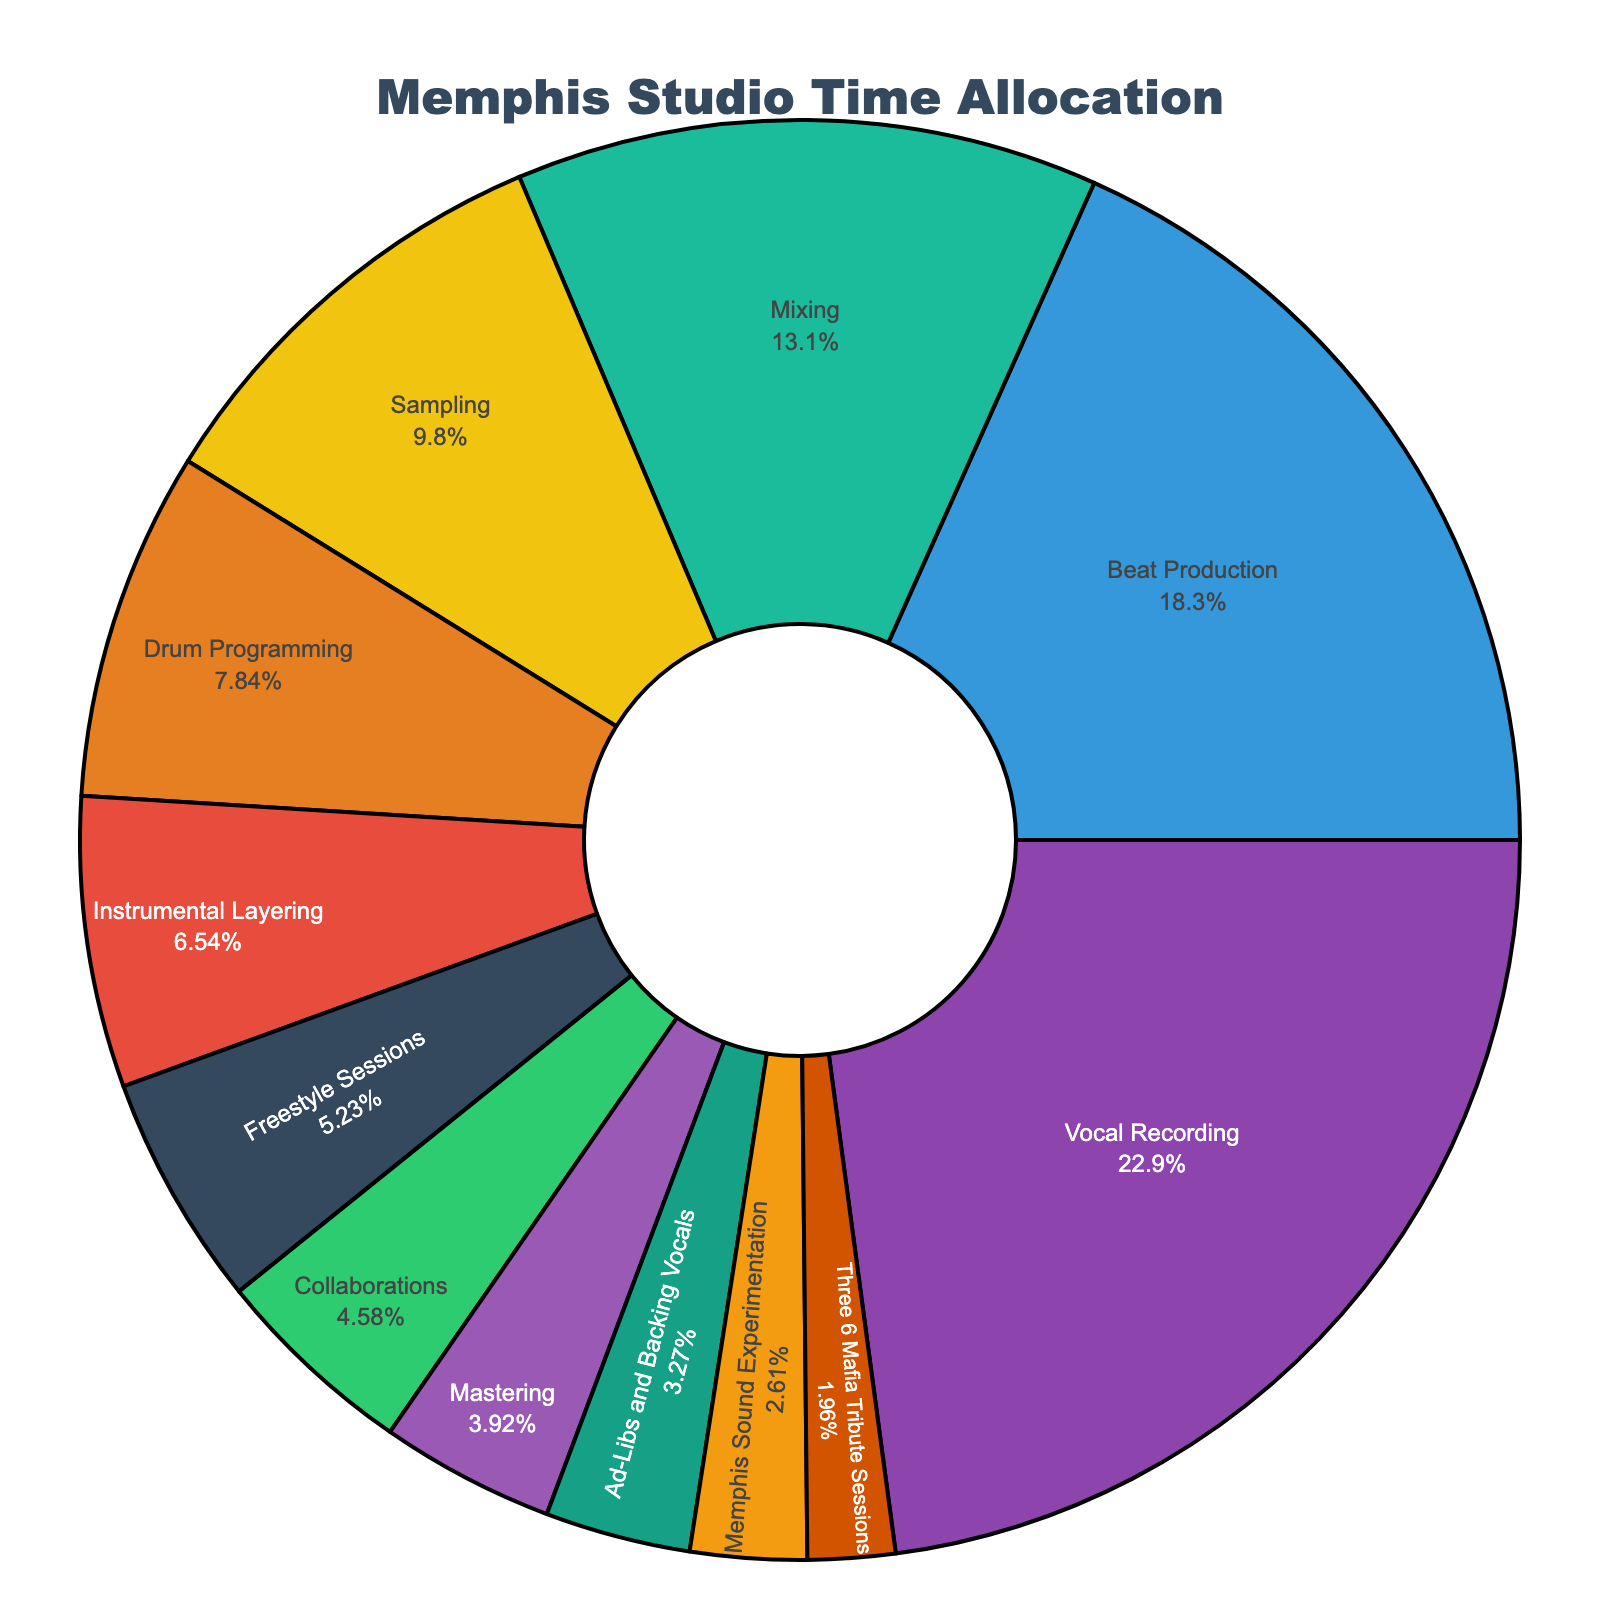How much time, in total, is dedicated to elements typical of Memphis hip-hop, specifically Memphis Sound Experimentation and Three 6 Mafia Tribute Sessions? To find the total time dedicated to Memphis-specific elements, add the hours for Memphis Sound Experimentation (4) and Three 6 Mafia Tribute Sessions (3). So, 4 + 3 = 7 hours.
Answer: 7 hours Which element takes up the largest portion of the studio time? Identify the element with the highest value. From the data, Vocal Recording has the highest number of hours (35).
Answer: Vocal Recording Compare Beat Production and Mixing: How many more hours are spent on one than the other? Subtract the hours spent on Mixing (20) from the hours spent on Beat Production (28). So, 28 - 20 = 8 hours.
Answer: 8 hours What is the most visually prominent color in the chart? The most visually prominent segment will likely be the largest one. The largest segment represents Vocal Recording, which is colored purple.
Answer: Purple Which elements combined make up less than 10% of the total studio time each? Calculate each element's percentage: Collaborations (7/153 ≈ 4.58%), Mastering (6/153 ≈ 3.92%), Ad-Libs and Backing Vocals (5/153 ≈ 3.27%), Memphis Sound Experimentation (4/153 ≈ 2.61%), and Three 6 Mafia Tribute Sessions (3/153 ≈ 1.96%).
Answer: Collaborations, Mastering, Ad-Libs and Backing Vocals, Memphis Sound Experimentation, Three 6 Mafia Tribute Sessions How does the time allocated to Freestyle Sessions compare to that for Collaborations in terms of hours? Compare the hours for Freestyle Sessions (8) and Collaborations (7). Freestyle Sessions have 1 hour more than Collaborations.
Answer: 1 hour more What fraction of the total studio time is spent on Drum Programming and Instrumental Layering combined? Add the hours for Drum Programming (12) and Instrumental Layering (10) to get 22, then divide by the total hours (153). So, 22/153 ≈ 0.144, which is approximately 14.4%.
Answer: 14.4% Is there a significant color contrast between the sections representing Sampling and Ad-Libs and Backing Vocals? Compare the colors of Sampling (a shade of green) and Ad-Libs and Backing Vocals (a shade of brown). Yes, there is a significant contrast as their colors are distinct from each other.
Answer: Yes How many elements have time allocations equal to or fewer than 10 hours? Count all elements with 10 or fewer hours: Instrumental Layering (10), Freestyle Sessions (8), Collaborations (7), Mastering (6), Ad-Libs and Backing Vocals (5), Memphis Sound Experimentation (4), Three 6 Mafia Tribute Sessions (3).
Answer: 7 elements 